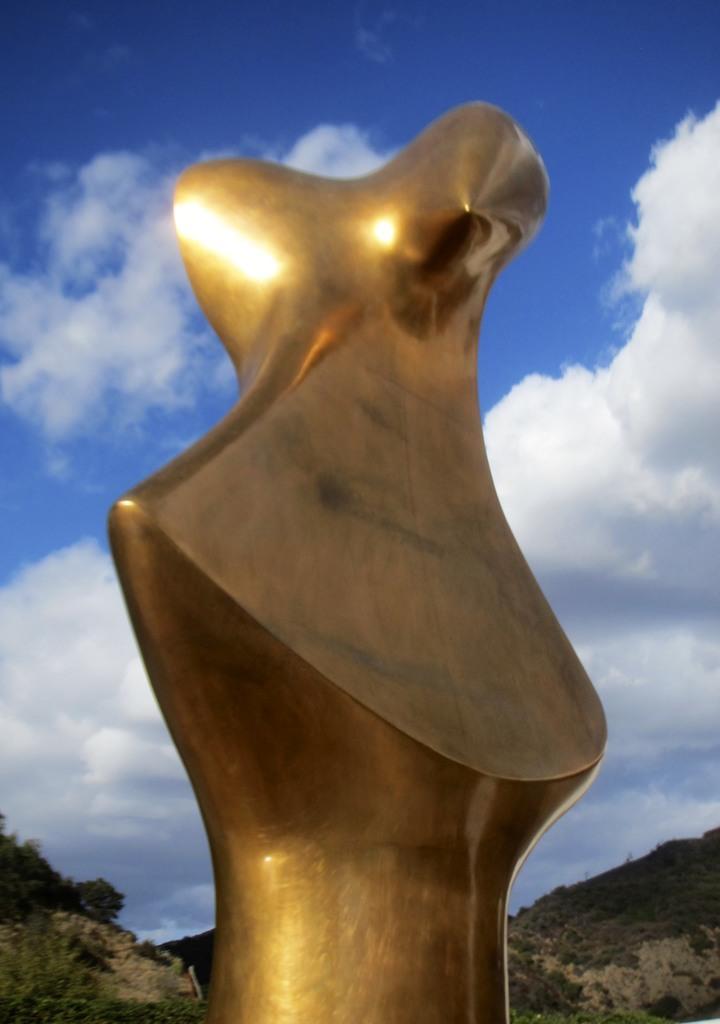How would you summarize this image in a sentence or two? In the image we can see there is a golden building. Behind there are hills which are covered with plants and trees. 